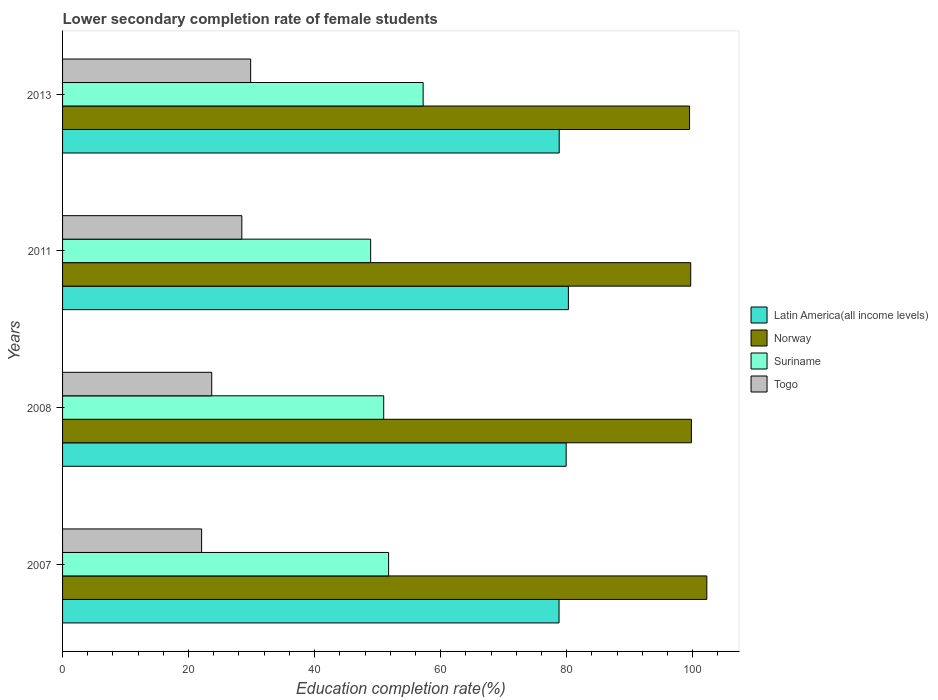How many different coloured bars are there?
Make the answer very short. 4. Are the number of bars per tick equal to the number of legend labels?
Give a very brief answer. Yes. How many bars are there on the 2nd tick from the top?
Give a very brief answer. 4. How many bars are there on the 2nd tick from the bottom?
Your answer should be compact. 4. What is the label of the 2nd group of bars from the top?
Your answer should be compact. 2011. What is the lower secondary completion rate of female students in Norway in 2013?
Make the answer very short. 99.51. Across all years, what is the maximum lower secondary completion rate of female students in Latin America(all income levels)?
Your answer should be compact. 80.28. Across all years, what is the minimum lower secondary completion rate of female students in Norway?
Keep it short and to the point. 99.51. In which year was the lower secondary completion rate of female students in Latin America(all income levels) maximum?
Provide a short and direct response. 2011. What is the total lower secondary completion rate of female students in Latin America(all income levels) in the graph?
Make the answer very short. 317.82. What is the difference between the lower secondary completion rate of female students in Latin America(all income levels) in 2007 and that in 2011?
Offer a very short reply. -1.48. What is the difference between the lower secondary completion rate of female students in Norway in 2013 and the lower secondary completion rate of female students in Togo in 2007?
Give a very brief answer. 77.44. What is the average lower secondary completion rate of female students in Togo per year?
Ensure brevity in your answer.  26.01. In the year 2011, what is the difference between the lower secondary completion rate of female students in Suriname and lower secondary completion rate of female students in Latin America(all income levels)?
Ensure brevity in your answer.  -31.38. In how many years, is the lower secondary completion rate of female students in Togo greater than 68 %?
Offer a very short reply. 0. What is the ratio of the lower secondary completion rate of female students in Norway in 2007 to that in 2011?
Make the answer very short. 1.03. Is the difference between the lower secondary completion rate of female students in Suriname in 2007 and 2008 greater than the difference between the lower secondary completion rate of female students in Latin America(all income levels) in 2007 and 2008?
Provide a short and direct response. Yes. What is the difference between the highest and the second highest lower secondary completion rate of female students in Norway?
Your answer should be compact. 2.45. What is the difference between the highest and the lowest lower secondary completion rate of female students in Norway?
Your response must be concise. 2.74. What does the 2nd bar from the top in 2011 represents?
Provide a short and direct response. Suriname. How many bars are there?
Your answer should be compact. 16. How many years are there in the graph?
Keep it short and to the point. 4. What is the difference between two consecutive major ticks on the X-axis?
Provide a succinct answer. 20. Does the graph contain grids?
Ensure brevity in your answer.  No. Where does the legend appear in the graph?
Your answer should be compact. Center right. How many legend labels are there?
Offer a terse response. 4. What is the title of the graph?
Provide a short and direct response. Lower secondary completion rate of female students. Does "Albania" appear as one of the legend labels in the graph?
Make the answer very short. No. What is the label or title of the X-axis?
Provide a succinct answer. Education completion rate(%). What is the label or title of the Y-axis?
Keep it short and to the point. Years. What is the Education completion rate(%) in Latin America(all income levels) in 2007?
Provide a succinct answer. 78.8. What is the Education completion rate(%) of Norway in 2007?
Your answer should be compact. 102.25. What is the Education completion rate(%) of Suriname in 2007?
Keep it short and to the point. 51.74. What is the Education completion rate(%) in Togo in 2007?
Make the answer very short. 22.07. What is the Education completion rate(%) in Latin America(all income levels) in 2008?
Provide a short and direct response. 79.92. What is the Education completion rate(%) of Norway in 2008?
Your answer should be compact. 99.8. What is the Education completion rate(%) of Suriname in 2008?
Your answer should be compact. 50.97. What is the Education completion rate(%) in Togo in 2008?
Give a very brief answer. 23.67. What is the Education completion rate(%) in Latin America(all income levels) in 2011?
Your response must be concise. 80.28. What is the Education completion rate(%) of Norway in 2011?
Your response must be concise. 99.69. What is the Education completion rate(%) in Suriname in 2011?
Provide a short and direct response. 48.9. What is the Education completion rate(%) in Togo in 2011?
Your response must be concise. 28.45. What is the Education completion rate(%) of Latin America(all income levels) in 2013?
Provide a succinct answer. 78.82. What is the Education completion rate(%) of Norway in 2013?
Provide a short and direct response. 99.51. What is the Education completion rate(%) of Suriname in 2013?
Provide a succinct answer. 57.23. What is the Education completion rate(%) of Togo in 2013?
Make the answer very short. 29.85. Across all years, what is the maximum Education completion rate(%) of Latin America(all income levels)?
Keep it short and to the point. 80.28. Across all years, what is the maximum Education completion rate(%) of Norway?
Your answer should be very brief. 102.25. Across all years, what is the maximum Education completion rate(%) in Suriname?
Your response must be concise. 57.23. Across all years, what is the maximum Education completion rate(%) in Togo?
Your response must be concise. 29.85. Across all years, what is the minimum Education completion rate(%) of Latin America(all income levels)?
Keep it short and to the point. 78.8. Across all years, what is the minimum Education completion rate(%) in Norway?
Your answer should be very brief. 99.51. Across all years, what is the minimum Education completion rate(%) in Suriname?
Provide a succinct answer. 48.9. Across all years, what is the minimum Education completion rate(%) of Togo?
Make the answer very short. 22.07. What is the total Education completion rate(%) in Latin America(all income levels) in the graph?
Your response must be concise. 317.82. What is the total Education completion rate(%) of Norway in the graph?
Give a very brief answer. 401.25. What is the total Education completion rate(%) of Suriname in the graph?
Your response must be concise. 208.84. What is the total Education completion rate(%) in Togo in the graph?
Your response must be concise. 104.05. What is the difference between the Education completion rate(%) in Latin America(all income levels) in 2007 and that in 2008?
Keep it short and to the point. -1.13. What is the difference between the Education completion rate(%) in Norway in 2007 and that in 2008?
Give a very brief answer. 2.45. What is the difference between the Education completion rate(%) in Suriname in 2007 and that in 2008?
Provide a succinct answer. 0.78. What is the difference between the Education completion rate(%) of Togo in 2007 and that in 2008?
Ensure brevity in your answer.  -1.6. What is the difference between the Education completion rate(%) in Latin America(all income levels) in 2007 and that in 2011?
Your answer should be compact. -1.48. What is the difference between the Education completion rate(%) of Norway in 2007 and that in 2011?
Your answer should be compact. 2.56. What is the difference between the Education completion rate(%) of Suriname in 2007 and that in 2011?
Give a very brief answer. 2.85. What is the difference between the Education completion rate(%) in Togo in 2007 and that in 2011?
Your answer should be compact. -6.38. What is the difference between the Education completion rate(%) in Latin America(all income levels) in 2007 and that in 2013?
Your answer should be compact. -0.03. What is the difference between the Education completion rate(%) in Norway in 2007 and that in 2013?
Your answer should be very brief. 2.74. What is the difference between the Education completion rate(%) in Suriname in 2007 and that in 2013?
Make the answer very short. -5.48. What is the difference between the Education completion rate(%) in Togo in 2007 and that in 2013?
Your answer should be compact. -7.78. What is the difference between the Education completion rate(%) of Latin America(all income levels) in 2008 and that in 2011?
Your answer should be very brief. -0.36. What is the difference between the Education completion rate(%) of Norway in 2008 and that in 2011?
Ensure brevity in your answer.  0.11. What is the difference between the Education completion rate(%) in Suriname in 2008 and that in 2011?
Your answer should be compact. 2.07. What is the difference between the Education completion rate(%) of Togo in 2008 and that in 2011?
Ensure brevity in your answer.  -4.78. What is the difference between the Education completion rate(%) in Latin America(all income levels) in 2008 and that in 2013?
Your answer should be very brief. 1.1. What is the difference between the Education completion rate(%) in Norway in 2008 and that in 2013?
Make the answer very short. 0.29. What is the difference between the Education completion rate(%) in Suriname in 2008 and that in 2013?
Your answer should be compact. -6.26. What is the difference between the Education completion rate(%) of Togo in 2008 and that in 2013?
Offer a terse response. -6.18. What is the difference between the Education completion rate(%) in Latin America(all income levels) in 2011 and that in 2013?
Provide a succinct answer. 1.46. What is the difference between the Education completion rate(%) of Norway in 2011 and that in 2013?
Give a very brief answer. 0.18. What is the difference between the Education completion rate(%) in Suriname in 2011 and that in 2013?
Make the answer very short. -8.33. What is the difference between the Education completion rate(%) in Togo in 2011 and that in 2013?
Make the answer very short. -1.4. What is the difference between the Education completion rate(%) of Latin America(all income levels) in 2007 and the Education completion rate(%) of Norway in 2008?
Provide a short and direct response. -21.01. What is the difference between the Education completion rate(%) of Latin America(all income levels) in 2007 and the Education completion rate(%) of Suriname in 2008?
Give a very brief answer. 27.83. What is the difference between the Education completion rate(%) of Latin America(all income levels) in 2007 and the Education completion rate(%) of Togo in 2008?
Give a very brief answer. 55.12. What is the difference between the Education completion rate(%) in Norway in 2007 and the Education completion rate(%) in Suriname in 2008?
Offer a very short reply. 51.28. What is the difference between the Education completion rate(%) of Norway in 2007 and the Education completion rate(%) of Togo in 2008?
Your answer should be very brief. 78.58. What is the difference between the Education completion rate(%) of Suriname in 2007 and the Education completion rate(%) of Togo in 2008?
Give a very brief answer. 28.07. What is the difference between the Education completion rate(%) of Latin America(all income levels) in 2007 and the Education completion rate(%) of Norway in 2011?
Provide a succinct answer. -20.9. What is the difference between the Education completion rate(%) in Latin America(all income levels) in 2007 and the Education completion rate(%) in Suriname in 2011?
Give a very brief answer. 29.9. What is the difference between the Education completion rate(%) of Latin America(all income levels) in 2007 and the Education completion rate(%) of Togo in 2011?
Provide a short and direct response. 50.35. What is the difference between the Education completion rate(%) in Norway in 2007 and the Education completion rate(%) in Suriname in 2011?
Your answer should be very brief. 53.35. What is the difference between the Education completion rate(%) of Norway in 2007 and the Education completion rate(%) of Togo in 2011?
Ensure brevity in your answer.  73.8. What is the difference between the Education completion rate(%) in Suriname in 2007 and the Education completion rate(%) in Togo in 2011?
Your response must be concise. 23.29. What is the difference between the Education completion rate(%) of Latin America(all income levels) in 2007 and the Education completion rate(%) of Norway in 2013?
Your response must be concise. -20.71. What is the difference between the Education completion rate(%) in Latin America(all income levels) in 2007 and the Education completion rate(%) in Suriname in 2013?
Keep it short and to the point. 21.57. What is the difference between the Education completion rate(%) in Latin America(all income levels) in 2007 and the Education completion rate(%) in Togo in 2013?
Ensure brevity in your answer.  48.94. What is the difference between the Education completion rate(%) in Norway in 2007 and the Education completion rate(%) in Suriname in 2013?
Your response must be concise. 45.02. What is the difference between the Education completion rate(%) of Norway in 2007 and the Education completion rate(%) of Togo in 2013?
Make the answer very short. 72.4. What is the difference between the Education completion rate(%) of Suriname in 2007 and the Education completion rate(%) of Togo in 2013?
Offer a terse response. 21.89. What is the difference between the Education completion rate(%) of Latin America(all income levels) in 2008 and the Education completion rate(%) of Norway in 2011?
Keep it short and to the point. -19.77. What is the difference between the Education completion rate(%) of Latin America(all income levels) in 2008 and the Education completion rate(%) of Suriname in 2011?
Offer a very short reply. 31.03. What is the difference between the Education completion rate(%) in Latin America(all income levels) in 2008 and the Education completion rate(%) in Togo in 2011?
Keep it short and to the point. 51.47. What is the difference between the Education completion rate(%) of Norway in 2008 and the Education completion rate(%) of Suriname in 2011?
Your answer should be compact. 50.9. What is the difference between the Education completion rate(%) in Norway in 2008 and the Education completion rate(%) in Togo in 2011?
Offer a terse response. 71.35. What is the difference between the Education completion rate(%) in Suriname in 2008 and the Education completion rate(%) in Togo in 2011?
Offer a terse response. 22.52. What is the difference between the Education completion rate(%) in Latin America(all income levels) in 2008 and the Education completion rate(%) in Norway in 2013?
Provide a short and direct response. -19.59. What is the difference between the Education completion rate(%) in Latin America(all income levels) in 2008 and the Education completion rate(%) in Suriname in 2013?
Offer a very short reply. 22.7. What is the difference between the Education completion rate(%) in Latin America(all income levels) in 2008 and the Education completion rate(%) in Togo in 2013?
Your response must be concise. 50.07. What is the difference between the Education completion rate(%) in Norway in 2008 and the Education completion rate(%) in Suriname in 2013?
Ensure brevity in your answer.  42.57. What is the difference between the Education completion rate(%) in Norway in 2008 and the Education completion rate(%) in Togo in 2013?
Your answer should be compact. 69.95. What is the difference between the Education completion rate(%) of Suriname in 2008 and the Education completion rate(%) of Togo in 2013?
Offer a very short reply. 21.11. What is the difference between the Education completion rate(%) in Latin America(all income levels) in 2011 and the Education completion rate(%) in Norway in 2013?
Offer a very short reply. -19.23. What is the difference between the Education completion rate(%) in Latin America(all income levels) in 2011 and the Education completion rate(%) in Suriname in 2013?
Your answer should be very brief. 23.05. What is the difference between the Education completion rate(%) in Latin America(all income levels) in 2011 and the Education completion rate(%) in Togo in 2013?
Make the answer very short. 50.43. What is the difference between the Education completion rate(%) of Norway in 2011 and the Education completion rate(%) of Suriname in 2013?
Give a very brief answer. 42.47. What is the difference between the Education completion rate(%) in Norway in 2011 and the Education completion rate(%) in Togo in 2013?
Offer a terse response. 69.84. What is the difference between the Education completion rate(%) of Suriname in 2011 and the Education completion rate(%) of Togo in 2013?
Your answer should be compact. 19.04. What is the average Education completion rate(%) of Latin America(all income levels) per year?
Keep it short and to the point. 79.46. What is the average Education completion rate(%) of Norway per year?
Ensure brevity in your answer.  100.31. What is the average Education completion rate(%) in Suriname per year?
Offer a very short reply. 52.21. What is the average Education completion rate(%) in Togo per year?
Provide a succinct answer. 26.01. In the year 2007, what is the difference between the Education completion rate(%) in Latin America(all income levels) and Education completion rate(%) in Norway?
Your answer should be very brief. -23.45. In the year 2007, what is the difference between the Education completion rate(%) in Latin America(all income levels) and Education completion rate(%) in Suriname?
Provide a short and direct response. 27.05. In the year 2007, what is the difference between the Education completion rate(%) in Latin America(all income levels) and Education completion rate(%) in Togo?
Provide a short and direct response. 56.73. In the year 2007, what is the difference between the Education completion rate(%) of Norway and Education completion rate(%) of Suriname?
Your answer should be very brief. 50.51. In the year 2007, what is the difference between the Education completion rate(%) of Norway and Education completion rate(%) of Togo?
Your answer should be very brief. 80.18. In the year 2007, what is the difference between the Education completion rate(%) of Suriname and Education completion rate(%) of Togo?
Make the answer very short. 29.67. In the year 2008, what is the difference between the Education completion rate(%) of Latin America(all income levels) and Education completion rate(%) of Norway?
Your response must be concise. -19.88. In the year 2008, what is the difference between the Education completion rate(%) of Latin America(all income levels) and Education completion rate(%) of Suriname?
Provide a short and direct response. 28.96. In the year 2008, what is the difference between the Education completion rate(%) of Latin America(all income levels) and Education completion rate(%) of Togo?
Provide a succinct answer. 56.25. In the year 2008, what is the difference between the Education completion rate(%) in Norway and Education completion rate(%) in Suriname?
Provide a short and direct response. 48.83. In the year 2008, what is the difference between the Education completion rate(%) of Norway and Education completion rate(%) of Togo?
Make the answer very short. 76.13. In the year 2008, what is the difference between the Education completion rate(%) of Suriname and Education completion rate(%) of Togo?
Provide a short and direct response. 27.29. In the year 2011, what is the difference between the Education completion rate(%) in Latin America(all income levels) and Education completion rate(%) in Norway?
Give a very brief answer. -19.41. In the year 2011, what is the difference between the Education completion rate(%) in Latin America(all income levels) and Education completion rate(%) in Suriname?
Your response must be concise. 31.38. In the year 2011, what is the difference between the Education completion rate(%) of Latin America(all income levels) and Education completion rate(%) of Togo?
Your response must be concise. 51.83. In the year 2011, what is the difference between the Education completion rate(%) in Norway and Education completion rate(%) in Suriname?
Provide a succinct answer. 50.8. In the year 2011, what is the difference between the Education completion rate(%) in Norway and Education completion rate(%) in Togo?
Keep it short and to the point. 71.24. In the year 2011, what is the difference between the Education completion rate(%) of Suriname and Education completion rate(%) of Togo?
Give a very brief answer. 20.45. In the year 2013, what is the difference between the Education completion rate(%) in Latin America(all income levels) and Education completion rate(%) in Norway?
Provide a short and direct response. -20.69. In the year 2013, what is the difference between the Education completion rate(%) in Latin America(all income levels) and Education completion rate(%) in Suriname?
Your response must be concise. 21.59. In the year 2013, what is the difference between the Education completion rate(%) of Latin America(all income levels) and Education completion rate(%) of Togo?
Offer a terse response. 48.97. In the year 2013, what is the difference between the Education completion rate(%) in Norway and Education completion rate(%) in Suriname?
Offer a terse response. 42.28. In the year 2013, what is the difference between the Education completion rate(%) of Norway and Education completion rate(%) of Togo?
Your answer should be compact. 69.66. In the year 2013, what is the difference between the Education completion rate(%) in Suriname and Education completion rate(%) in Togo?
Give a very brief answer. 27.37. What is the ratio of the Education completion rate(%) of Latin America(all income levels) in 2007 to that in 2008?
Your answer should be compact. 0.99. What is the ratio of the Education completion rate(%) of Norway in 2007 to that in 2008?
Give a very brief answer. 1.02. What is the ratio of the Education completion rate(%) of Suriname in 2007 to that in 2008?
Ensure brevity in your answer.  1.02. What is the ratio of the Education completion rate(%) of Togo in 2007 to that in 2008?
Keep it short and to the point. 0.93. What is the ratio of the Education completion rate(%) of Latin America(all income levels) in 2007 to that in 2011?
Keep it short and to the point. 0.98. What is the ratio of the Education completion rate(%) in Norway in 2007 to that in 2011?
Provide a succinct answer. 1.03. What is the ratio of the Education completion rate(%) in Suriname in 2007 to that in 2011?
Your answer should be very brief. 1.06. What is the ratio of the Education completion rate(%) of Togo in 2007 to that in 2011?
Provide a short and direct response. 0.78. What is the ratio of the Education completion rate(%) of Norway in 2007 to that in 2013?
Keep it short and to the point. 1.03. What is the ratio of the Education completion rate(%) in Suriname in 2007 to that in 2013?
Your answer should be compact. 0.9. What is the ratio of the Education completion rate(%) in Togo in 2007 to that in 2013?
Your answer should be compact. 0.74. What is the ratio of the Education completion rate(%) of Latin America(all income levels) in 2008 to that in 2011?
Your answer should be compact. 1. What is the ratio of the Education completion rate(%) in Norway in 2008 to that in 2011?
Offer a very short reply. 1. What is the ratio of the Education completion rate(%) of Suriname in 2008 to that in 2011?
Provide a succinct answer. 1.04. What is the ratio of the Education completion rate(%) of Togo in 2008 to that in 2011?
Make the answer very short. 0.83. What is the ratio of the Education completion rate(%) of Latin America(all income levels) in 2008 to that in 2013?
Your answer should be very brief. 1.01. What is the ratio of the Education completion rate(%) of Suriname in 2008 to that in 2013?
Provide a succinct answer. 0.89. What is the ratio of the Education completion rate(%) of Togo in 2008 to that in 2013?
Your answer should be very brief. 0.79. What is the ratio of the Education completion rate(%) in Latin America(all income levels) in 2011 to that in 2013?
Provide a succinct answer. 1.02. What is the ratio of the Education completion rate(%) in Suriname in 2011 to that in 2013?
Provide a short and direct response. 0.85. What is the ratio of the Education completion rate(%) in Togo in 2011 to that in 2013?
Ensure brevity in your answer.  0.95. What is the difference between the highest and the second highest Education completion rate(%) in Latin America(all income levels)?
Provide a short and direct response. 0.36. What is the difference between the highest and the second highest Education completion rate(%) in Norway?
Provide a succinct answer. 2.45. What is the difference between the highest and the second highest Education completion rate(%) in Suriname?
Provide a succinct answer. 5.48. What is the difference between the highest and the second highest Education completion rate(%) of Togo?
Provide a succinct answer. 1.4. What is the difference between the highest and the lowest Education completion rate(%) in Latin America(all income levels)?
Your answer should be compact. 1.48. What is the difference between the highest and the lowest Education completion rate(%) of Norway?
Your answer should be very brief. 2.74. What is the difference between the highest and the lowest Education completion rate(%) of Suriname?
Give a very brief answer. 8.33. What is the difference between the highest and the lowest Education completion rate(%) in Togo?
Provide a short and direct response. 7.78. 